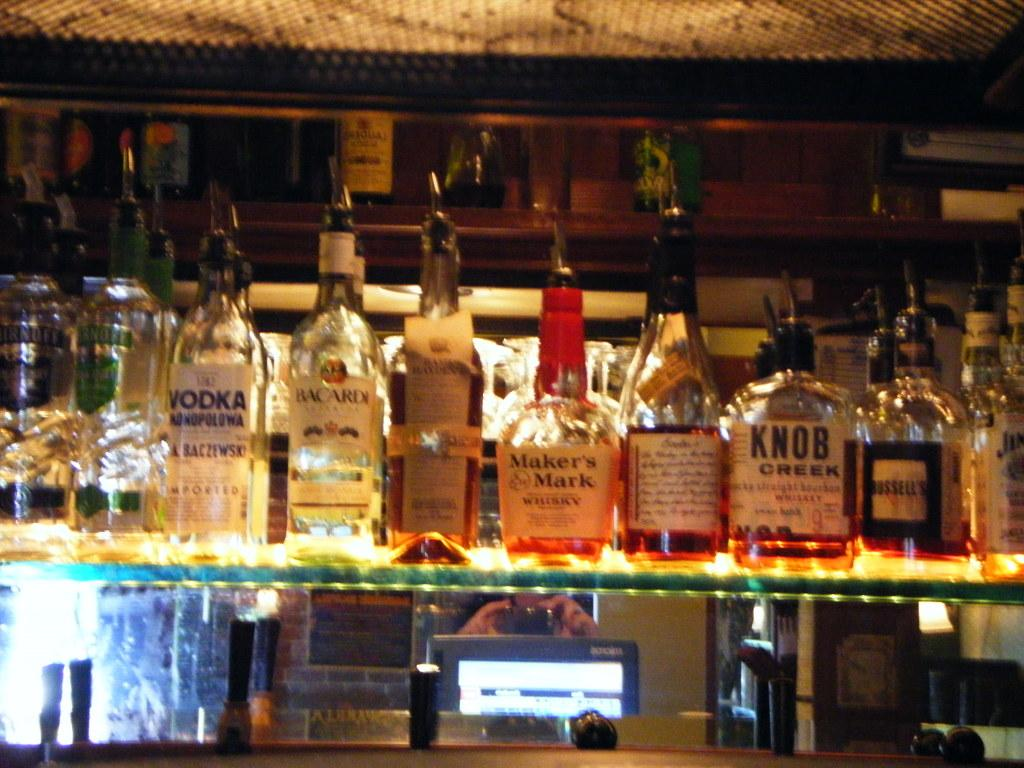<image>
Present a compact description of the photo's key features. A bar shelf including bottles of Maker's Mark and Knob Creek. 